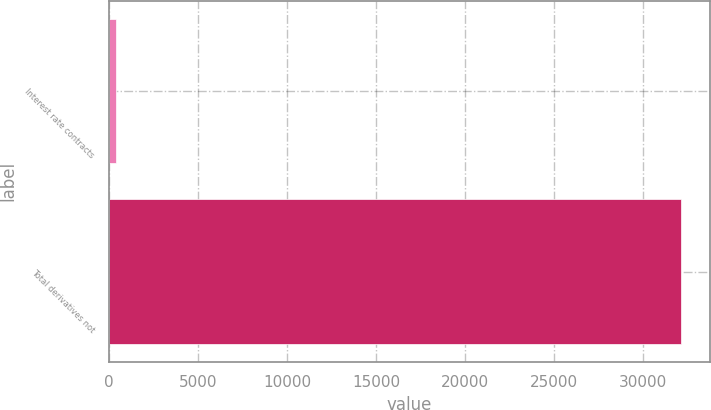<chart> <loc_0><loc_0><loc_500><loc_500><bar_chart><fcel>Interest rate contracts<fcel>Total derivatives not<nl><fcel>407<fcel>32123<nl></chart> 